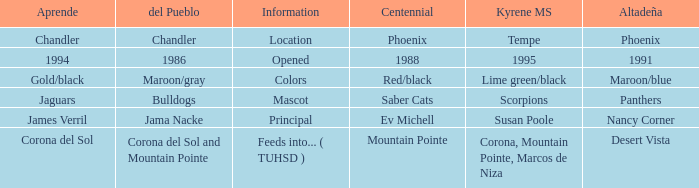What kind of Altadeña has del Pueblo of maroon/gray? Maroon/blue. 